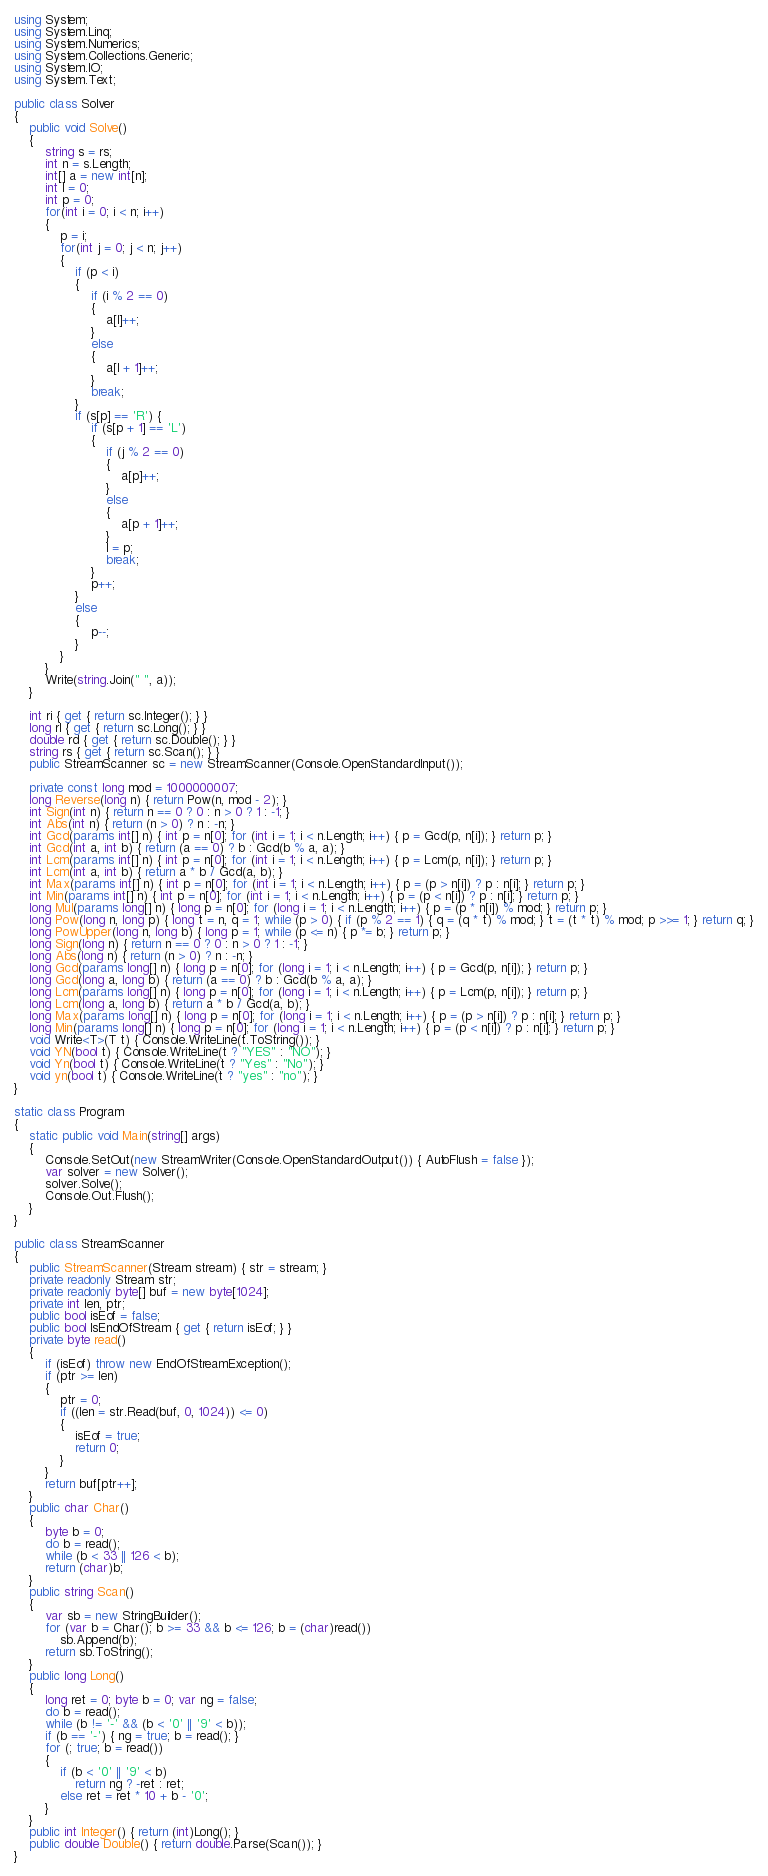<code> <loc_0><loc_0><loc_500><loc_500><_C#_>using System;
using System.Linq;
using System.Numerics;
using System.Collections.Generic;
using System.IO;
using System.Text;

public class Solver
{
    public void Solve()
    {
        string s = rs;
        int n = s.Length;
        int[] a = new int[n];
        int l = 0;
        int p = 0;
        for(int i = 0; i < n; i++)
        {
            p = i;
            for(int j = 0; j < n; j++)
            {
                if (p < i)
                {
                    if (i % 2 == 0)
                    {
                        a[l]++;
                    }
                    else
                    {
                        a[l + 1]++;
                    }
                    break;
                }
                if (s[p] == 'R') {
                    if (s[p + 1] == 'L')
                    {
                        if (j % 2 == 0)
                        {
                            a[p]++;
                        }
                        else
                        {
                            a[p + 1]++;
                        }
                        l = p;
                        break;
                    }
                    p++;
                }
                else
                {
                    p--;
                }
            }
        }
        Write(string.Join(" ", a));
    }

    int ri { get { return sc.Integer(); } }
    long rl { get { return sc.Long(); } }
    double rd { get { return sc.Double(); } }
    string rs { get { return sc.Scan(); } }
    public StreamScanner sc = new StreamScanner(Console.OpenStandardInput());
    
    private const long mod = 1000000007;
    long Reverse(long n) { return Pow(n, mod - 2); }
    int Sign(int n) { return n == 0 ? 0 : n > 0 ? 1 : -1; }
    int Abs(int n) { return (n > 0) ? n : -n; }
    int Gcd(params int[] n) { int p = n[0]; for (int i = 1; i < n.Length; i++) { p = Gcd(p, n[i]); } return p; }
    int Gcd(int a, int b) { return (a == 0) ? b : Gcd(b % a, a); }
    int Lcm(params int[] n) { int p = n[0]; for (int i = 1; i < n.Length; i++) { p = Lcm(p, n[i]); } return p; }
    int Lcm(int a, int b) { return a * b / Gcd(a, b); }
    int Max(params int[] n) { int p = n[0]; for (int i = 1; i < n.Length; i++) { p = (p > n[i]) ? p : n[i]; } return p; }
    int Min(params int[] n) { int p = n[0]; for (int i = 1; i < n.Length; i++) { p = (p < n[i]) ? p : n[i]; } return p; }
    long Mul(params long[] n) { long p = n[0]; for (long i = 1; i < n.Length; i++) { p = (p * n[i]) % mod; } return p; }
    long Pow(long n, long p) { long t = n, q = 1; while (p > 0) { if (p % 2 == 1) { q = (q * t) % mod; } t = (t * t) % mod; p >>= 1; } return q; }
    long PowUpper(long n, long b) { long p = 1; while (p <= n) { p *= b; } return p; }
    long Sign(long n) { return n == 0 ? 0 : n > 0 ? 1 : -1; }
    long Abs(long n) { return (n > 0) ? n : -n; }
    long Gcd(params long[] n) { long p = n[0]; for (long i = 1; i < n.Length; i++) { p = Gcd(p, n[i]); } return p; }
    long Gcd(long a, long b) { return (a == 0) ? b : Gcd(b % a, a); }
    long Lcm(params long[] n) { long p = n[0]; for (long i = 1; i < n.Length; i++) { p = Lcm(p, n[i]); } return p; }
    long Lcm(long a, long b) { return a * b / Gcd(a, b); }
    long Max(params long[] n) { long p = n[0]; for (long i = 1; i < n.Length; i++) { p = (p > n[i]) ? p : n[i]; } return p; }
    long Min(params long[] n) { long p = n[0]; for (long i = 1; i < n.Length; i++) { p = (p < n[i]) ? p : n[i]; } return p; }
    void Write<T>(T t) { Console.WriteLine(t.ToString()); }
    void YN(bool t) { Console.WriteLine(t ? "YES" : "NO"); }
    void Yn(bool t) { Console.WriteLine(t ? "Yes" : "No"); }
    void yn(bool t) { Console.WriteLine(t ? "yes" : "no"); }
}

static class Program
{
    static public void Main(string[] args)
    {
        Console.SetOut(new StreamWriter(Console.OpenStandardOutput()) { AutoFlush = false });
        var solver = new Solver();
        solver.Solve();
        Console.Out.Flush();
    }
}

public class StreamScanner
{
    public StreamScanner(Stream stream) { str = stream; }
    private readonly Stream str;
    private readonly byte[] buf = new byte[1024];
    private int len, ptr;
    public bool isEof = false;
    public bool IsEndOfStream { get { return isEof; } }
    private byte read()
    {
        if (isEof) throw new EndOfStreamException();
        if (ptr >= len)
        {
            ptr = 0;
            if ((len = str.Read(buf, 0, 1024)) <= 0)
            {
                isEof = true;
                return 0;
            }
        }
        return buf[ptr++];
    }
    public char Char()
    {
        byte b = 0;
        do b = read();
        while (b < 33 || 126 < b);
        return (char)b;
    }
    public string Scan()
    {
        var sb = new StringBuilder();
        for (var b = Char(); b >= 33 && b <= 126; b = (char)read())
            sb.Append(b);
        return sb.ToString();
    }
    public long Long()
    {
        long ret = 0; byte b = 0; var ng = false;
        do b = read();
        while (b != '-' && (b < '0' || '9' < b));
        if (b == '-') { ng = true; b = read(); }
        for (; true; b = read())
        {
            if (b < '0' || '9' < b)
                return ng ? -ret : ret;
            else ret = ret * 10 + b - '0';
        }
    }
    public int Integer() { return (int)Long(); }
    public double Double() { return double.Parse(Scan()); }
}
</code> 